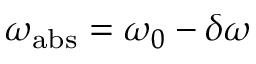<formula> <loc_0><loc_0><loc_500><loc_500>\omega _ { a b s } = \omega _ { 0 } - \delta \omega</formula> 